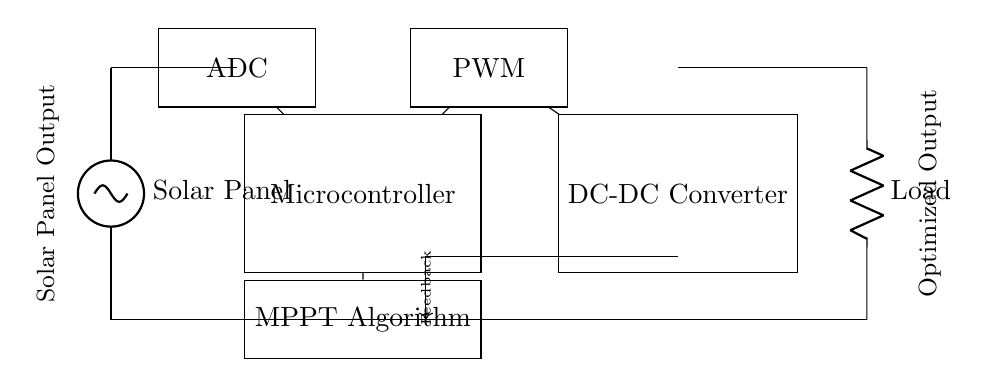What type of component is the ADC? The ADC, or Analog to Digital Converter, is a type of microcontroller component designed to convert analog signals from the solar panel into digital signals for processing.
Answer: Microcontroller What is the main purpose of the MPPT Algorithm? The MPPT Algorithm, or Maximum Power Point Tracking Algorithm, is designed to optimize the power output of the solar panel by adjusting the operating point to maximize energy harvested under varying conditions.
Answer: Optimize power output How many components are connected in series in this circuit? In the circuit diagram, there are two series connections: one from the solar panel to the ADC and another from the DC-DC Converter to the Load.
Answer: Two What does PWM stand for in this circuit? PWM stands for Pulse Width Modulation, which is a technique used in the circuit for controlling the output voltage of the DC-DC Converter based on the processed data from the microcontroller.
Answer: Pulse Width Modulation What is the flow direction of feedback in this circuit? The feedback flows from the DC-DC Converter back to the microcontroller through the designated feedback connection, which allows for continual adjustment of the PWM signal based on the output.
Answer: Back to microcontroller 